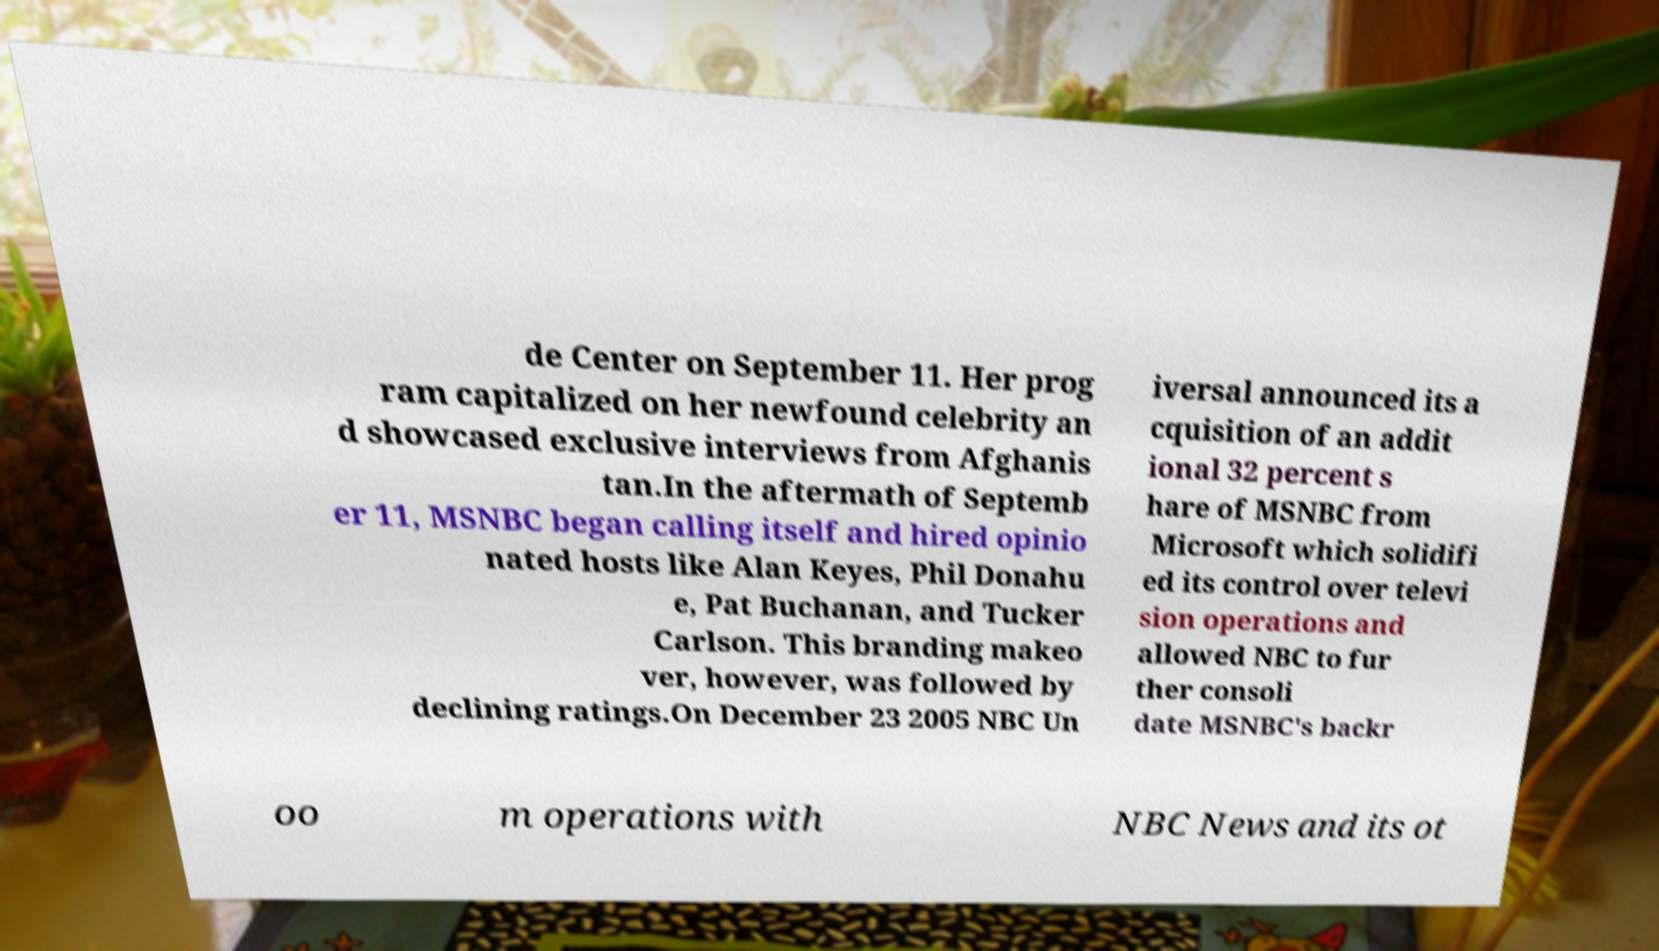Could you assist in decoding the text presented in this image and type it out clearly? de Center on September 11. Her prog ram capitalized on her newfound celebrity an d showcased exclusive interviews from Afghanis tan.In the aftermath of Septemb er 11, MSNBC began calling itself and hired opinio nated hosts like Alan Keyes, Phil Donahu e, Pat Buchanan, and Tucker Carlson. This branding makeo ver, however, was followed by declining ratings.On December 23 2005 NBC Un iversal announced its a cquisition of an addit ional 32 percent s hare of MSNBC from Microsoft which solidifi ed its control over televi sion operations and allowed NBC to fur ther consoli date MSNBC's backr oo m operations with NBC News and its ot 